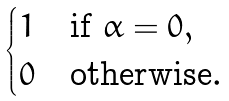<formula> <loc_0><loc_0><loc_500><loc_500>\begin{cases} 1 & \text {if\ } \alpha = 0 , \\ 0 & \text {otherwise} . \end{cases}</formula> 